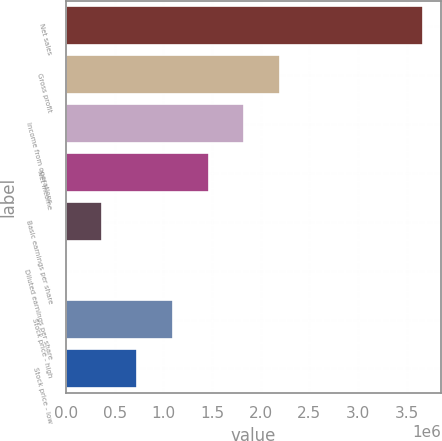Convert chart to OTSL. <chart><loc_0><loc_0><loc_500><loc_500><bar_chart><fcel>Net sales<fcel>Gross profit<fcel>Income from operations<fcel>Net income<fcel>Basic earnings per share<fcel>Diluted earnings per share<fcel>Stock price - high<fcel>Stock price - low<nl><fcel>3.66531e+06<fcel>2.19919e+06<fcel>1.83266e+06<fcel>1.46613e+06<fcel>366535<fcel>4.47<fcel>1.0996e+06<fcel>733065<nl></chart> 